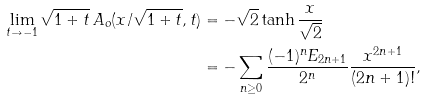<formula> <loc_0><loc_0><loc_500><loc_500>\lim _ { t \to - 1 } \sqrt { 1 + t } \, A _ { o } ( x / \sqrt { 1 + t } , t ) & = - \sqrt { 2 } \tanh \frac { x } { \sqrt { 2 } } \\ & = - \sum _ { n \geq 0 } \frac { ( - 1 ) ^ { n } E _ { 2 n + 1 } } { 2 ^ { n } } \frac { x ^ { 2 n + 1 } } { ( 2 n + 1 ) ! } ,</formula> 